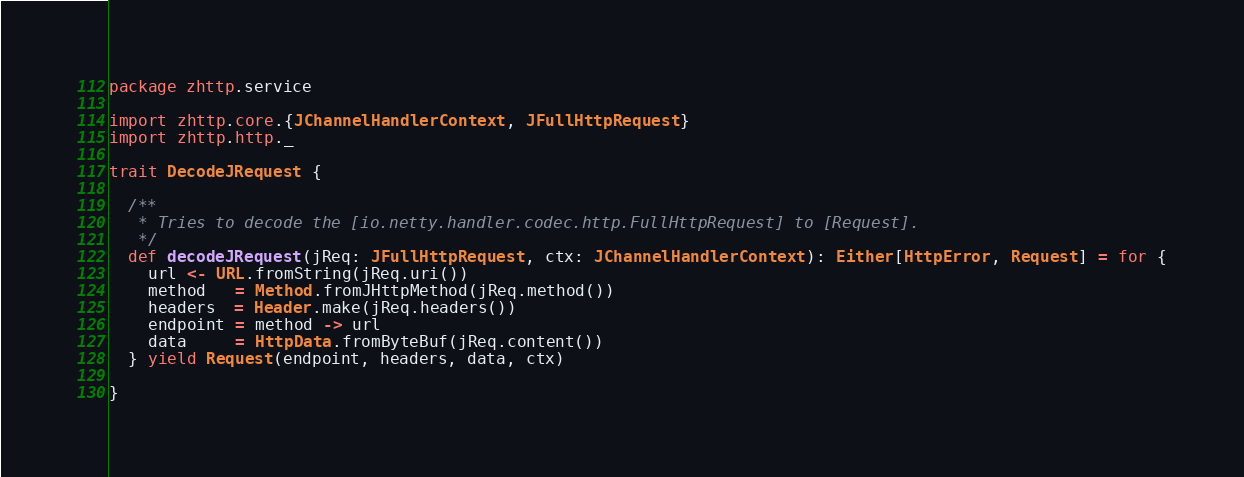Convert code to text. <code><loc_0><loc_0><loc_500><loc_500><_Scala_>package zhttp.service

import zhttp.core.{JChannelHandlerContext, JFullHttpRequest}
import zhttp.http._

trait DecodeJRequest {

  /**
   * Tries to decode the [io.netty.handler.codec.http.FullHttpRequest] to [Request].
   */
  def decodeJRequest(jReq: JFullHttpRequest, ctx: JChannelHandlerContext): Either[HttpError, Request] = for {
    url <- URL.fromString(jReq.uri())
    method   = Method.fromJHttpMethod(jReq.method())
    headers  = Header.make(jReq.headers())
    endpoint = method -> url
    data     = HttpData.fromByteBuf(jReq.content())
  } yield Request(endpoint, headers, data, ctx)

}
</code> 